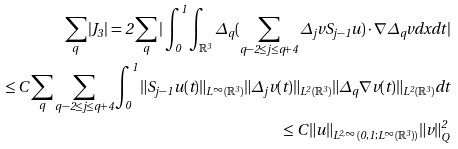<formula> <loc_0><loc_0><loc_500><loc_500>\sum _ { q } | J _ { 3 } | = 2 \sum _ { q } | \int _ { 0 } ^ { 1 } \int _ { \mathbb { R } ^ { 3 } } \Delta _ { q } ( \sum _ { q - 2 \leq j \leq q + 4 } \Delta _ { j } v S _ { j - 1 } u ) \cdot \nabla \Delta _ { q } v d x d t | \\ \leq C \sum _ { q } \sum _ { q - 2 \leq j \leq q + 4 } \int _ { 0 } ^ { 1 } \| S _ { j - 1 } u ( t ) \| _ { L ^ { \infty } ( \mathbb { R } ^ { 3 } ) } \| \Delta _ { j } v ( t ) \| _ { L ^ { 2 } ( \mathbb { R } ^ { 3 } ) } \| \Delta _ { q } \nabla v ( t ) \| _ { L ^ { 2 } ( \mathbb { R } ^ { 3 } ) } d t \\ \leq C \| u \| _ { L ^ { 2 , \infty } ( 0 , 1 ; L ^ { \infty } ( \mathbb { R } ^ { 3 } ) ) } \| v \| _ { Q } ^ { 2 }</formula> 